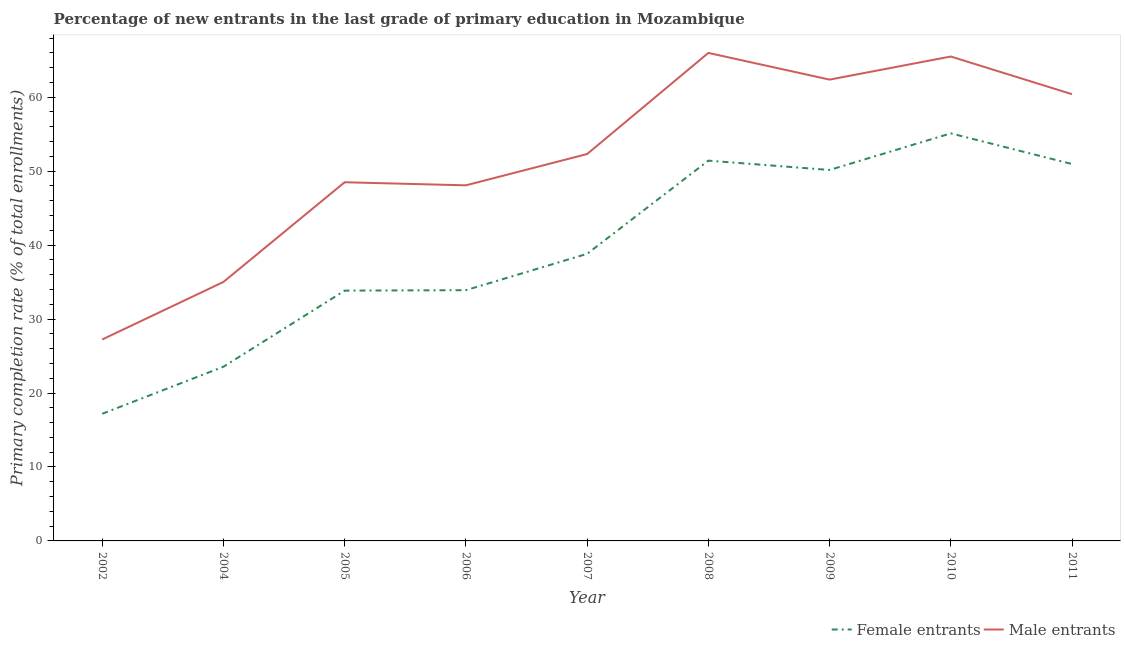How many different coloured lines are there?
Make the answer very short. 2. Does the line corresponding to primary completion rate of male entrants intersect with the line corresponding to primary completion rate of female entrants?
Your response must be concise. No. Is the number of lines equal to the number of legend labels?
Give a very brief answer. Yes. What is the primary completion rate of female entrants in 2005?
Provide a short and direct response. 33.84. Across all years, what is the maximum primary completion rate of female entrants?
Your answer should be very brief. 55.11. Across all years, what is the minimum primary completion rate of female entrants?
Provide a short and direct response. 17.19. In which year was the primary completion rate of male entrants maximum?
Offer a very short reply. 2008. What is the total primary completion rate of female entrants in the graph?
Make the answer very short. 354.96. What is the difference between the primary completion rate of female entrants in 2005 and that in 2008?
Keep it short and to the point. -17.58. What is the difference between the primary completion rate of male entrants in 2006 and the primary completion rate of female entrants in 2010?
Offer a very short reply. -7.03. What is the average primary completion rate of male entrants per year?
Your answer should be compact. 51.71. In the year 2004, what is the difference between the primary completion rate of female entrants and primary completion rate of male entrants?
Provide a short and direct response. -11.46. In how many years, is the primary completion rate of female entrants greater than 36 %?
Your response must be concise. 5. What is the ratio of the primary completion rate of female entrants in 2005 to that in 2010?
Your answer should be very brief. 0.61. Is the primary completion rate of female entrants in 2005 less than that in 2009?
Provide a short and direct response. Yes. Is the difference between the primary completion rate of female entrants in 2009 and 2011 greater than the difference between the primary completion rate of male entrants in 2009 and 2011?
Your answer should be compact. No. What is the difference between the highest and the second highest primary completion rate of female entrants?
Keep it short and to the point. 3.69. What is the difference between the highest and the lowest primary completion rate of male entrants?
Make the answer very short. 38.75. Does the primary completion rate of female entrants monotonically increase over the years?
Provide a short and direct response. No. Is the primary completion rate of female entrants strictly greater than the primary completion rate of male entrants over the years?
Ensure brevity in your answer.  No. Is the primary completion rate of male entrants strictly less than the primary completion rate of female entrants over the years?
Provide a succinct answer. No. What is the difference between two consecutive major ticks on the Y-axis?
Your answer should be very brief. 10. Does the graph contain grids?
Provide a short and direct response. No. What is the title of the graph?
Make the answer very short. Percentage of new entrants in the last grade of primary education in Mozambique. What is the label or title of the X-axis?
Offer a very short reply. Year. What is the label or title of the Y-axis?
Make the answer very short. Primary completion rate (% of total enrollments). What is the Primary completion rate (% of total enrollments) of Female entrants in 2002?
Give a very brief answer. 17.19. What is the Primary completion rate (% of total enrollments) in Male entrants in 2002?
Offer a terse response. 27.24. What is the Primary completion rate (% of total enrollments) in Female entrants in 2004?
Give a very brief answer. 23.55. What is the Primary completion rate (% of total enrollments) of Male entrants in 2004?
Provide a short and direct response. 35.02. What is the Primary completion rate (% of total enrollments) of Female entrants in 2005?
Offer a very short reply. 33.84. What is the Primary completion rate (% of total enrollments) of Male entrants in 2005?
Ensure brevity in your answer.  48.5. What is the Primary completion rate (% of total enrollments) in Female entrants in 2006?
Give a very brief answer. 33.9. What is the Primary completion rate (% of total enrollments) in Male entrants in 2006?
Make the answer very short. 48.08. What is the Primary completion rate (% of total enrollments) of Female entrants in 2007?
Provide a succinct answer. 38.82. What is the Primary completion rate (% of total enrollments) in Male entrants in 2007?
Provide a short and direct response. 52.31. What is the Primary completion rate (% of total enrollments) of Female entrants in 2008?
Keep it short and to the point. 51.42. What is the Primary completion rate (% of total enrollments) in Male entrants in 2008?
Make the answer very short. 65.99. What is the Primary completion rate (% of total enrollments) of Female entrants in 2009?
Give a very brief answer. 50.16. What is the Primary completion rate (% of total enrollments) in Male entrants in 2009?
Give a very brief answer. 62.38. What is the Primary completion rate (% of total enrollments) in Female entrants in 2010?
Offer a very short reply. 55.11. What is the Primary completion rate (% of total enrollments) of Male entrants in 2010?
Offer a very short reply. 65.5. What is the Primary completion rate (% of total enrollments) of Female entrants in 2011?
Offer a terse response. 50.96. What is the Primary completion rate (% of total enrollments) of Male entrants in 2011?
Provide a succinct answer. 60.4. Across all years, what is the maximum Primary completion rate (% of total enrollments) in Female entrants?
Provide a succinct answer. 55.11. Across all years, what is the maximum Primary completion rate (% of total enrollments) of Male entrants?
Give a very brief answer. 65.99. Across all years, what is the minimum Primary completion rate (% of total enrollments) in Female entrants?
Provide a succinct answer. 17.19. Across all years, what is the minimum Primary completion rate (% of total enrollments) in Male entrants?
Offer a terse response. 27.24. What is the total Primary completion rate (% of total enrollments) of Female entrants in the graph?
Provide a succinct answer. 354.96. What is the total Primary completion rate (% of total enrollments) of Male entrants in the graph?
Keep it short and to the point. 465.41. What is the difference between the Primary completion rate (% of total enrollments) in Female entrants in 2002 and that in 2004?
Ensure brevity in your answer.  -6.36. What is the difference between the Primary completion rate (% of total enrollments) in Male entrants in 2002 and that in 2004?
Keep it short and to the point. -7.78. What is the difference between the Primary completion rate (% of total enrollments) in Female entrants in 2002 and that in 2005?
Your answer should be very brief. -16.65. What is the difference between the Primary completion rate (% of total enrollments) of Male entrants in 2002 and that in 2005?
Keep it short and to the point. -21.26. What is the difference between the Primary completion rate (% of total enrollments) of Female entrants in 2002 and that in 2006?
Offer a terse response. -16.71. What is the difference between the Primary completion rate (% of total enrollments) in Male entrants in 2002 and that in 2006?
Ensure brevity in your answer.  -20.84. What is the difference between the Primary completion rate (% of total enrollments) in Female entrants in 2002 and that in 2007?
Give a very brief answer. -21.63. What is the difference between the Primary completion rate (% of total enrollments) of Male entrants in 2002 and that in 2007?
Offer a terse response. -25.07. What is the difference between the Primary completion rate (% of total enrollments) of Female entrants in 2002 and that in 2008?
Ensure brevity in your answer.  -34.23. What is the difference between the Primary completion rate (% of total enrollments) in Male entrants in 2002 and that in 2008?
Give a very brief answer. -38.75. What is the difference between the Primary completion rate (% of total enrollments) in Female entrants in 2002 and that in 2009?
Make the answer very short. -32.97. What is the difference between the Primary completion rate (% of total enrollments) in Male entrants in 2002 and that in 2009?
Provide a short and direct response. -35.14. What is the difference between the Primary completion rate (% of total enrollments) in Female entrants in 2002 and that in 2010?
Provide a short and direct response. -37.92. What is the difference between the Primary completion rate (% of total enrollments) in Male entrants in 2002 and that in 2010?
Your answer should be very brief. -38.26. What is the difference between the Primary completion rate (% of total enrollments) in Female entrants in 2002 and that in 2011?
Your response must be concise. -33.77. What is the difference between the Primary completion rate (% of total enrollments) in Male entrants in 2002 and that in 2011?
Your answer should be compact. -33.16. What is the difference between the Primary completion rate (% of total enrollments) of Female entrants in 2004 and that in 2005?
Your answer should be compact. -10.29. What is the difference between the Primary completion rate (% of total enrollments) of Male entrants in 2004 and that in 2005?
Offer a very short reply. -13.48. What is the difference between the Primary completion rate (% of total enrollments) in Female entrants in 2004 and that in 2006?
Give a very brief answer. -10.35. What is the difference between the Primary completion rate (% of total enrollments) in Male entrants in 2004 and that in 2006?
Offer a very short reply. -13.06. What is the difference between the Primary completion rate (% of total enrollments) of Female entrants in 2004 and that in 2007?
Keep it short and to the point. -15.27. What is the difference between the Primary completion rate (% of total enrollments) of Male entrants in 2004 and that in 2007?
Your answer should be compact. -17.3. What is the difference between the Primary completion rate (% of total enrollments) in Female entrants in 2004 and that in 2008?
Offer a terse response. -27.87. What is the difference between the Primary completion rate (% of total enrollments) in Male entrants in 2004 and that in 2008?
Your response must be concise. -30.97. What is the difference between the Primary completion rate (% of total enrollments) of Female entrants in 2004 and that in 2009?
Provide a succinct answer. -26.61. What is the difference between the Primary completion rate (% of total enrollments) in Male entrants in 2004 and that in 2009?
Provide a succinct answer. -27.36. What is the difference between the Primary completion rate (% of total enrollments) of Female entrants in 2004 and that in 2010?
Your answer should be very brief. -31.55. What is the difference between the Primary completion rate (% of total enrollments) of Male entrants in 2004 and that in 2010?
Offer a terse response. -30.48. What is the difference between the Primary completion rate (% of total enrollments) in Female entrants in 2004 and that in 2011?
Your answer should be compact. -27.41. What is the difference between the Primary completion rate (% of total enrollments) in Male entrants in 2004 and that in 2011?
Offer a terse response. -25.39. What is the difference between the Primary completion rate (% of total enrollments) of Female entrants in 2005 and that in 2006?
Offer a terse response. -0.06. What is the difference between the Primary completion rate (% of total enrollments) of Male entrants in 2005 and that in 2006?
Offer a terse response. 0.42. What is the difference between the Primary completion rate (% of total enrollments) of Female entrants in 2005 and that in 2007?
Provide a short and direct response. -4.98. What is the difference between the Primary completion rate (% of total enrollments) in Male entrants in 2005 and that in 2007?
Make the answer very short. -3.81. What is the difference between the Primary completion rate (% of total enrollments) of Female entrants in 2005 and that in 2008?
Offer a very short reply. -17.58. What is the difference between the Primary completion rate (% of total enrollments) in Male entrants in 2005 and that in 2008?
Your answer should be compact. -17.49. What is the difference between the Primary completion rate (% of total enrollments) of Female entrants in 2005 and that in 2009?
Your answer should be very brief. -16.32. What is the difference between the Primary completion rate (% of total enrollments) in Male entrants in 2005 and that in 2009?
Ensure brevity in your answer.  -13.88. What is the difference between the Primary completion rate (% of total enrollments) of Female entrants in 2005 and that in 2010?
Your response must be concise. -21.26. What is the difference between the Primary completion rate (% of total enrollments) of Male entrants in 2005 and that in 2010?
Provide a short and direct response. -17. What is the difference between the Primary completion rate (% of total enrollments) in Female entrants in 2005 and that in 2011?
Your answer should be very brief. -17.12. What is the difference between the Primary completion rate (% of total enrollments) of Male entrants in 2005 and that in 2011?
Give a very brief answer. -11.9. What is the difference between the Primary completion rate (% of total enrollments) in Female entrants in 2006 and that in 2007?
Provide a short and direct response. -4.92. What is the difference between the Primary completion rate (% of total enrollments) of Male entrants in 2006 and that in 2007?
Keep it short and to the point. -4.23. What is the difference between the Primary completion rate (% of total enrollments) in Female entrants in 2006 and that in 2008?
Provide a short and direct response. -17.52. What is the difference between the Primary completion rate (% of total enrollments) in Male entrants in 2006 and that in 2008?
Offer a very short reply. -17.9. What is the difference between the Primary completion rate (% of total enrollments) in Female entrants in 2006 and that in 2009?
Your answer should be very brief. -16.26. What is the difference between the Primary completion rate (% of total enrollments) of Male entrants in 2006 and that in 2009?
Provide a succinct answer. -14.3. What is the difference between the Primary completion rate (% of total enrollments) of Female entrants in 2006 and that in 2010?
Your answer should be very brief. -21.2. What is the difference between the Primary completion rate (% of total enrollments) of Male entrants in 2006 and that in 2010?
Provide a succinct answer. -17.42. What is the difference between the Primary completion rate (% of total enrollments) in Female entrants in 2006 and that in 2011?
Keep it short and to the point. -17.06. What is the difference between the Primary completion rate (% of total enrollments) in Male entrants in 2006 and that in 2011?
Your response must be concise. -12.32. What is the difference between the Primary completion rate (% of total enrollments) of Female entrants in 2007 and that in 2008?
Offer a terse response. -12.6. What is the difference between the Primary completion rate (% of total enrollments) of Male entrants in 2007 and that in 2008?
Offer a very short reply. -13.67. What is the difference between the Primary completion rate (% of total enrollments) of Female entrants in 2007 and that in 2009?
Ensure brevity in your answer.  -11.34. What is the difference between the Primary completion rate (% of total enrollments) in Male entrants in 2007 and that in 2009?
Your response must be concise. -10.07. What is the difference between the Primary completion rate (% of total enrollments) in Female entrants in 2007 and that in 2010?
Ensure brevity in your answer.  -16.29. What is the difference between the Primary completion rate (% of total enrollments) in Male entrants in 2007 and that in 2010?
Provide a short and direct response. -13.19. What is the difference between the Primary completion rate (% of total enrollments) in Female entrants in 2007 and that in 2011?
Offer a very short reply. -12.14. What is the difference between the Primary completion rate (% of total enrollments) of Male entrants in 2007 and that in 2011?
Provide a succinct answer. -8.09. What is the difference between the Primary completion rate (% of total enrollments) in Female entrants in 2008 and that in 2009?
Offer a very short reply. 1.26. What is the difference between the Primary completion rate (% of total enrollments) in Male entrants in 2008 and that in 2009?
Your answer should be very brief. 3.61. What is the difference between the Primary completion rate (% of total enrollments) in Female entrants in 2008 and that in 2010?
Offer a terse response. -3.69. What is the difference between the Primary completion rate (% of total enrollments) of Male entrants in 2008 and that in 2010?
Your answer should be compact. 0.49. What is the difference between the Primary completion rate (% of total enrollments) in Female entrants in 2008 and that in 2011?
Your answer should be compact. 0.46. What is the difference between the Primary completion rate (% of total enrollments) in Male entrants in 2008 and that in 2011?
Give a very brief answer. 5.58. What is the difference between the Primary completion rate (% of total enrollments) in Female entrants in 2009 and that in 2010?
Make the answer very short. -4.95. What is the difference between the Primary completion rate (% of total enrollments) in Male entrants in 2009 and that in 2010?
Provide a succinct answer. -3.12. What is the difference between the Primary completion rate (% of total enrollments) of Female entrants in 2009 and that in 2011?
Your answer should be very brief. -0.8. What is the difference between the Primary completion rate (% of total enrollments) in Male entrants in 2009 and that in 2011?
Offer a terse response. 1.97. What is the difference between the Primary completion rate (% of total enrollments) in Female entrants in 2010 and that in 2011?
Your response must be concise. 4.14. What is the difference between the Primary completion rate (% of total enrollments) in Male entrants in 2010 and that in 2011?
Provide a short and direct response. 5.1. What is the difference between the Primary completion rate (% of total enrollments) in Female entrants in 2002 and the Primary completion rate (% of total enrollments) in Male entrants in 2004?
Give a very brief answer. -17.82. What is the difference between the Primary completion rate (% of total enrollments) of Female entrants in 2002 and the Primary completion rate (% of total enrollments) of Male entrants in 2005?
Provide a succinct answer. -31.31. What is the difference between the Primary completion rate (% of total enrollments) in Female entrants in 2002 and the Primary completion rate (% of total enrollments) in Male entrants in 2006?
Give a very brief answer. -30.89. What is the difference between the Primary completion rate (% of total enrollments) of Female entrants in 2002 and the Primary completion rate (% of total enrollments) of Male entrants in 2007?
Provide a succinct answer. -35.12. What is the difference between the Primary completion rate (% of total enrollments) of Female entrants in 2002 and the Primary completion rate (% of total enrollments) of Male entrants in 2008?
Provide a succinct answer. -48.79. What is the difference between the Primary completion rate (% of total enrollments) of Female entrants in 2002 and the Primary completion rate (% of total enrollments) of Male entrants in 2009?
Give a very brief answer. -45.19. What is the difference between the Primary completion rate (% of total enrollments) of Female entrants in 2002 and the Primary completion rate (% of total enrollments) of Male entrants in 2010?
Provide a short and direct response. -48.31. What is the difference between the Primary completion rate (% of total enrollments) in Female entrants in 2002 and the Primary completion rate (% of total enrollments) in Male entrants in 2011?
Your response must be concise. -43.21. What is the difference between the Primary completion rate (% of total enrollments) in Female entrants in 2004 and the Primary completion rate (% of total enrollments) in Male entrants in 2005?
Your answer should be very brief. -24.95. What is the difference between the Primary completion rate (% of total enrollments) in Female entrants in 2004 and the Primary completion rate (% of total enrollments) in Male entrants in 2006?
Your answer should be compact. -24.53. What is the difference between the Primary completion rate (% of total enrollments) of Female entrants in 2004 and the Primary completion rate (% of total enrollments) of Male entrants in 2007?
Keep it short and to the point. -28.76. What is the difference between the Primary completion rate (% of total enrollments) of Female entrants in 2004 and the Primary completion rate (% of total enrollments) of Male entrants in 2008?
Give a very brief answer. -42.43. What is the difference between the Primary completion rate (% of total enrollments) in Female entrants in 2004 and the Primary completion rate (% of total enrollments) in Male entrants in 2009?
Your response must be concise. -38.82. What is the difference between the Primary completion rate (% of total enrollments) in Female entrants in 2004 and the Primary completion rate (% of total enrollments) in Male entrants in 2010?
Ensure brevity in your answer.  -41.95. What is the difference between the Primary completion rate (% of total enrollments) in Female entrants in 2004 and the Primary completion rate (% of total enrollments) in Male entrants in 2011?
Provide a short and direct response. -36.85. What is the difference between the Primary completion rate (% of total enrollments) of Female entrants in 2005 and the Primary completion rate (% of total enrollments) of Male entrants in 2006?
Ensure brevity in your answer.  -14.24. What is the difference between the Primary completion rate (% of total enrollments) in Female entrants in 2005 and the Primary completion rate (% of total enrollments) in Male entrants in 2007?
Offer a terse response. -18.47. What is the difference between the Primary completion rate (% of total enrollments) in Female entrants in 2005 and the Primary completion rate (% of total enrollments) in Male entrants in 2008?
Offer a terse response. -32.14. What is the difference between the Primary completion rate (% of total enrollments) in Female entrants in 2005 and the Primary completion rate (% of total enrollments) in Male entrants in 2009?
Keep it short and to the point. -28.53. What is the difference between the Primary completion rate (% of total enrollments) in Female entrants in 2005 and the Primary completion rate (% of total enrollments) in Male entrants in 2010?
Provide a succinct answer. -31.66. What is the difference between the Primary completion rate (% of total enrollments) of Female entrants in 2005 and the Primary completion rate (% of total enrollments) of Male entrants in 2011?
Provide a succinct answer. -26.56. What is the difference between the Primary completion rate (% of total enrollments) in Female entrants in 2006 and the Primary completion rate (% of total enrollments) in Male entrants in 2007?
Ensure brevity in your answer.  -18.41. What is the difference between the Primary completion rate (% of total enrollments) in Female entrants in 2006 and the Primary completion rate (% of total enrollments) in Male entrants in 2008?
Give a very brief answer. -32.08. What is the difference between the Primary completion rate (% of total enrollments) of Female entrants in 2006 and the Primary completion rate (% of total enrollments) of Male entrants in 2009?
Ensure brevity in your answer.  -28.47. What is the difference between the Primary completion rate (% of total enrollments) of Female entrants in 2006 and the Primary completion rate (% of total enrollments) of Male entrants in 2010?
Your answer should be very brief. -31.6. What is the difference between the Primary completion rate (% of total enrollments) of Female entrants in 2006 and the Primary completion rate (% of total enrollments) of Male entrants in 2011?
Ensure brevity in your answer.  -26.5. What is the difference between the Primary completion rate (% of total enrollments) of Female entrants in 2007 and the Primary completion rate (% of total enrollments) of Male entrants in 2008?
Your response must be concise. -27.17. What is the difference between the Primary completion rate (% of total enrollments) in Female entrants in 2007 and the Primary completion rate (% of total enrollments) in Male entrants in 2009?
Provide a succinct answer. -23.56. What is the difference between the Primary completion rate (% of total enrollments) of Female entrants in 2007 and the Primary completion rate (% of total enrollments) of Male entrants in 2010?
Provide a short and direct response. -26.68. What is the difference between the Primary completion rate (% of total enrollments) of Female entrants in 2007 and the Primary completion rate (% of total enrollments) of Male entrants in 2011?
Provide a succinct answer. -21.58. What is the difference between the Primary completion rate (% of total enrollments) in Female entrants in 2008 and the Primary completion rate (% of total enrollments) in Male entrants in 2009?
Your answer should be very brief. -10.96. What is the difference between the Primary completion rate (% of total enrollments) in Female entrants in 2008 and the Primary completion rate (% of total enrollments) in Male entrants in 2010?
Provide a short and direct response. -14.08. What is the difference between the Primary completion rate (% of total enrollments) of Female entrants in 2008 and the Primary completion rate (% of total enrollments) of Male entrants in 2011?
Your answer should be compact. -8.98. What is the difference between the Primary completion rate (% of total enrollments) of Female entrants in 2009 and the Primary completion rate (% of total enrollments) of Male entrants in 2010?
Provide a succinct answer. -15.34. What is the difference between the Primary completion rate (% of total enrollments) of Female entrants in 2009 and the Primary completion rate (% of total enrollments) of Male entrants in 2011?
Your response must be concise. -10.24. What is the difference between the Primary completion rate (% of total enrollments) in Female entrants in 2010 and the Primary completion rate (% of total enrollments) in Male entrants in 2011?
Give a very brief answer. -5.3. What is the average Primary completion rate (% of total enrollments) in Female entrants per year?
Provide a short and direct response. 39.44. What is the average Primary completion rate (% of total enrollments) in Male entrants per year?
Offer a terse response. 51.71. In the year 2002, what is the difference between the Primary completion rate (% of total enrollments) in Female entrants and Primary completion rate (% of total enrollments) in Male entrants?
Offer a very short reply. -10.05. In the year 2004, what is the difference between the Primary completion rate (% of total enrollments) in Female entrants and Primary completion rate (% of total enrollments) in Male entrants?
Ensure brevity in your answer.  -11.46. In the year 2005, what is the difference between the Primary completion rate (% of total enrollments) of Female entrants and Primary completion rate (% of total enrollments) of Male entrants?
Offer a terse response. -14.65. In the year 2006, what is the difference between the Primary completion rate (% of total enrollments) of Female entrants and Primary completion rate (% of total enrollments) of Male entrants?
Your answer should be very brief. -14.18. In the year 2007, what is the difference between the Primary completion rate (% of total enrollments) of Female entrants and Primary completion rate (% of total enrollments) of Male entrants?
Your answer should be very brief. -13.49. In the year 2008, what is the difference between the Primary completion rate (% of total enrollments) of Female entrants and Primary completion rate (% of total enrollments) of Male entrants?
Your response must be concise. -14.57. In the year 2009, what is the difference between the Primary completion rate (% of total enrollments) in Female entrants and Primary completion rate (% of total enrollments) in Male entrants?
Give a very brief answer. -12.22. In the year 2010, what is the difference between the Primary completion rate (% of total enrollments) of Female entrants and Primary completion rate (% of total enrollments) of Male entrants?
Keep it short and to the point. -10.39. In the year 2011, what is the difference between the Primary completion rate (% of total enrollments) of Female entrants and Primary completion rate (% of total enrollments) of Male entrants?
Provide a short and direct response. -9.44. What is the ratio of the Primary completion rate (% of total enrollments) of Female entrants in 2002 to that in 2004?
Your response must be concise. 0.73. What is the ratio of the Primary completion rate (% of total enrollments) in Male entrants in 2002 to that in 2004?
Give a very brief answer. 0.78. What is the ratio of the Primary completion rate (% of total enrollments) in Female entrants in 2002 to that in 2005?
Keep it short and to the point. 0.51. What is the ratio of the Primary completion rate (% of total enrollments) in Male entrants in 2002 to that in 2005?
Keep it short and to the point. 0.56. What is the ratio of the Primary completion rate (% of total enrollments) in Female entrants in 2002 to that in 2006?
Provide a short and direct response. 0.51. What is the ratio of the Primary completion rate (% of total enrollments) of Male entrants in 2002 to that in 2006?
Ensure brevity in your answer.  0.57. What is the ratio of the Primary completion rate (% of total enrollments) of Female entrants in 2002 to that in 2007?
Offer a terse response. 0.44. What is the ratio of the Primary completion rate (% of total enrollments) in Male entrants in 2002 to that in 2007?
Provide a short and direct response. 0.52. What is the ratio of the Primary completion rate (% of total enrollments) in Female entrants in 2002 to that in 2008?
Your answer should be very brief. 0.33. What is the ratio of the Primary completion rate (% of total enrollments) of Male entrants in 2002 to that in 2008?
Make the answer very short. 0.41. What is the ratio of the Primary completion rate (% of total enrollments) in Female entrants in 2002 to that in 2009?
Ensure brevity in your answer.  0.34. What is the ratio of the Primary completion rate (% of total enrollments) in Male entrants in 2002 to that in 2009?
Offer a very short reply. 0.44. What is the ratio of the Primary completion rate (% of total enrollments) in Female entrants in 2002 to that in 2010?
Make the answer very short. 0.31. What is the ratio of the Primary completion rate (% of total enrollments) of Male entrants in 2002 to that in 2010?
Offer a very short reply. 0.42. What is the ratio of the Primary completion rate (% of total enrollments) of Female entrants in 2002 to that in 2011?
Your response must be concise. 0.34. What is the ratio of the Primary completion rate (% of total enrollments) of Male entrants in 2002 to that in 2011?
Give a very brief answer. 0.45. What is the ratio of the Primary completion rate (% of total enrollments) in Female entrants in 2004 to that in 2005?
Provide a short and direct response. 0.7. What is the ratio of the Primary completion rate (% of total enrollments) of Male entrants in 2004 to that in 2005?
Provide a short and direct response. 0.72. What is the ratio of the Primary completion rate (% of total enrollments) in Female entrants in 2004 to that in 2006?
Keep it short and to the point. 0.69. What is the ratio of the Primary completion rate (% of total enrollments) in Male entrants in 2004 to that in 2006?
Your answer should be very brief. 0.73. What is the ratio of the Primary completion rate (% of total enrollments) of Female entrants in 2004 to that in 2007?
Make the answer very short. 0.61. What is the ratio of the Primary completion rate (% of total enrollments) in Male entrants in 2004 to that in 2007?
Your response must be concise. 0.67. What is the ratio of the Primary completion rate (% of total enrollments) in Female entrants in 2004 to that in 2008?
Your answer should be compact. 0.46. What is the ratio of the Primary completion rate (% of total enrollments) of Male entrants in 2004 to that in 2008?
Your answer should be compact. 0.53. What is the ratio of the Primary completion rate (% of total enrollments) of Female entrants in 2004 to that in 2009?
Give a very brief answer. 0.47. What is the ratio of the Primary completion rate (% of total enrollments) in Male entrants in 2004 to that in 2009?
Your answer should be very brief. 0.56. What is the ratio of the Primary completion rate (% of total enrollments) of Female entrants in 2004 to that in 2010?
Make the answer very short. 0.43. What is the ratio of the Primary completion rate (% of total enrollments) of Male entrants in 2004 to that in 2010?
Your response must be concise. 0.53. What is the ratio of the Primary completion rate (% of total enrollments) of Female entrants in 2004 to that in 2011?
Provide a succinct answer. 0.46. What is the ratio of the Primary completion rate (% of total enrollments) of Male entrants in 2004 to that in 2011?
Make the answer very short. 0.58. What is the ratio of the Primary completion rate (% of total enrollments) of Male entrants in 2005 to that in 2006?
Your answer should be compact. 1.01. What is the ratio of the Primary completion rate (% of total enrollments) of Female entrants in 2005 to that in 2007?
Your answer should be very brief. 0.87. What is the ratio of the Primary completion rate (% of total enrollments) in Male entrants in 2005 to that in 2007?
Give a very brief answer. 0.93. What is the ratio of the Primary completion rate (% of total enrollments) in Female entrants in 2005 to that in 2008?
Offer a very short reply. 0.66. What is the ratio of the Primary completion rate (% of total enrollments) of Male entrants in 2005 to that in 2008?
Provide a short and direct response. 0.73. What is the ratio of the Primary completion rate (% of total enrollments) in Female entrants in 2005 to that in 2009?
Offer a very short reply. 0.67. What is the ratio of the Primary completion rate (% of total enrollments) of Male entrants in 2005 to that in 2009?
Make the answer very short. 0.78. What is the ratio of the Primary completion rate (% of total enrollments) of Female entrants in 2005 to that in 2010?
Offer a very short reply. 0.61. What is the ratio of the Primary completion rate (% of total enrollments) in Male entrants in 2005 to that in 2010?
Make the answer very short. 0.74. What is the ratio of the Primary completion rate (% of total enrollments) in Female entrants in 2005 to that in 2011?
Your response must be concise. 0.66. What is the ratio of the Primary completion rate (% of total enrollments) of Male entrants in 2005 to that in 2011?
Give a very brief answer. 0.8. What is the ratio of the Primary completion rate (% of total enrollments) in Female entrants in 2006 to that in 2007?
Your response must be concise. 0.87. What is the ratio of the Primary completion rate (% of total enrollments) in Male entrants in 2006 to that in 2007?
Provide a short and direct response. 0.92. What is the ratio of the Primary completion rate (% of total enrollments) in Female entrants in 2006 to that in 2008?
Provide a succinct answer. 0.66. What is the ratio of the Primary completion rate (% of total enrollments) in Male entrants in 2006 to that in 2008?
Ensure brevity in your answer.  0.73. What is the ratio of the Primary completion rate (% of total enrollments) in Female entrants in 2006 to that in 2009?
Your response must be concise. 0.68. What is the ratio of the Primary completion rate (% of total enrollments) of Male entrants in 2006 to that in 2009?
Provide a short and direct response. 0.77. What is the ratio of the Primary completion rate (% of total enrollments) in Female entrants in 2006 to that in 2010?
Your response must be concise. 0.62. What is the ratio of the Primary completion rate (% of total enrollments) in Male entrants in 2006 to that in 2010?
Keep it short and to the point. 0.73. What is the ratio of the Primary completion rate (% of total enrollments) in Female entrants in 2006 to that in 2011?
Offer a terse response. 0.67. What is the ratio of the Primary completion rate (% of total enrollments) of Male entrants in 2006 to that in 2011?
Keep it short and to the point. 0.8. What is the ratio of the Primary completion rate (% of total enrollments) of Female entrants in 2007 to that in 2008?
Give a very brief answer. 0.76. What is the ratio of the Primary completion rate (% of total enrollments) in Male entrants in 2007 to that in 2008?
Keep it short and to the point. 0.79. What is the ratio of the Primary completion rate (% of total enrollments) of Female entrants in 2007 to that in 2009?
Your response must be concise. 0.77. What is the ratio of the Primary completion rate (% of total enrollments) of Male entrants in 2007 to that in 2009?
Offer a very short reply. 0.84. What is the ratio of the Primary completion rate (% of total enrollments) of Female entrants in 2007 to that in 2010?
Offer a very short reply. 0.7. What is the ratio of the Primary completion rate (% of total enrollments) in Male entrants in 2007 to that in 2010?
Ensure brevity in your answer.  0.8. What is the ratio of the Primary completion rate (% of total enrollments) in Female entrants in 2007 to that in 2011?
Your answer should be compact. 0.76. What is the ratio of the Primary completion rate (% of total enrollments) in Male entrants in 2007 to that in 2011?
Your answer should be compact. 0.87. What is the ratio of the Primary completion rate (% of total enrollments) of Female entrants in 2008 to that in 2009?
Offer a terse response. 1.03. What is the ratio of the Primary completion rate (% of total enrollments) of Male entrants in 2008 to that in 2009?
Give a very brief answer. 1.06. What is the ratio of the Primary completion rate (% of total enrollments) in Female entrants in 2008 to that in 2010?
Offer a terse response. 0.93. What is the ratio of the Primary completion rate (% of total enrollments) of Male entrants in 2008 to that in 2010?
Your answer should be very brief. 1.01. What is the ratio of the Primary completion rate (% of total enrollments) of Male entrants in 2008 to that in 2011?
Your response must be concise. 1.09. What is the ratio of the Primary completion rate (% of total enrollments) in Female entrants in 2009 to that in 2010?
Provide a short and direct response. 0.91. What is the ratio of the Primary completion rate (% of total enrollments) in Male entrants in 2009 to that in 2010?
Keep it short and to the point. 0.95. What is the ratio of the Primary completion rate (% of total enrollments) of Female entrants in 2009 to that in 2011?
Offer a very short reply. 0.98. What is the ratio of the Primary completion rate (% of total enrollments) in Male entrants in 2009 to that in 2011?
Your answer should be very brief. 1.03. What is the ratio of the Primary completion rate (% of total enrollments) in Female entrants in 2010 to that in 2011?
Your response must be concise. 1.08. What is the ratio of the Primary completion rate (% of total enrollments) in Male entrants in 2010 to that in 2011?
Offer a very short reply. 1.08. What is the difference between the highest and the second highest Primary completion rate (% of total enrollments) in Female entrants?
Offer a terse response. 3.69. What is the difference between the highest and the second highest Primary completion rate (% of total enrollments) in Male entrants?
Give a very brief answer. 0.49. What is the difference between the highest and the lowest Primary completion rate (% of total enrollments) of Female entrants?
Ensure brevity in your answer.  37.92. What is the difference between the highest and the lowest Primary completion rate (% of total enrollments) of Male entrants?
Your answer should be very brief. 38.75. 